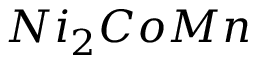Convert formula to latex. <formula><loc_0><loc_0><loc_500><loc_500>N i _ { 2 } C o M n</formula> 